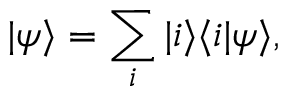Convert formula to latex. <formula><loc_0><loc_0><loc_500><loc_500>| \psi \rangle = \sum _ { i } | i \rangle \langle i | \psi \rangle ,</formula> 